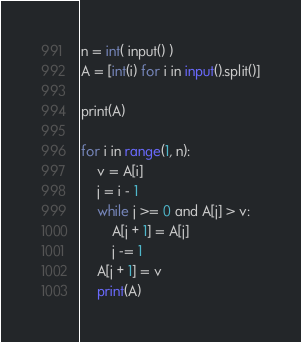Convert code to text. <code><loc_0><loc_0><loc_500><loc_500><_Java_>n = int( input() )
A = [int(i) for i in input().split()]

print(A)

for i in range(1, n):
    v = A[i]
    j = i - 1
    while j >= 0 and A[j] > v:
        A[j + 1] = A[j]
        j -= 1
    A[j + 1] = v
    print(A)

</code> 